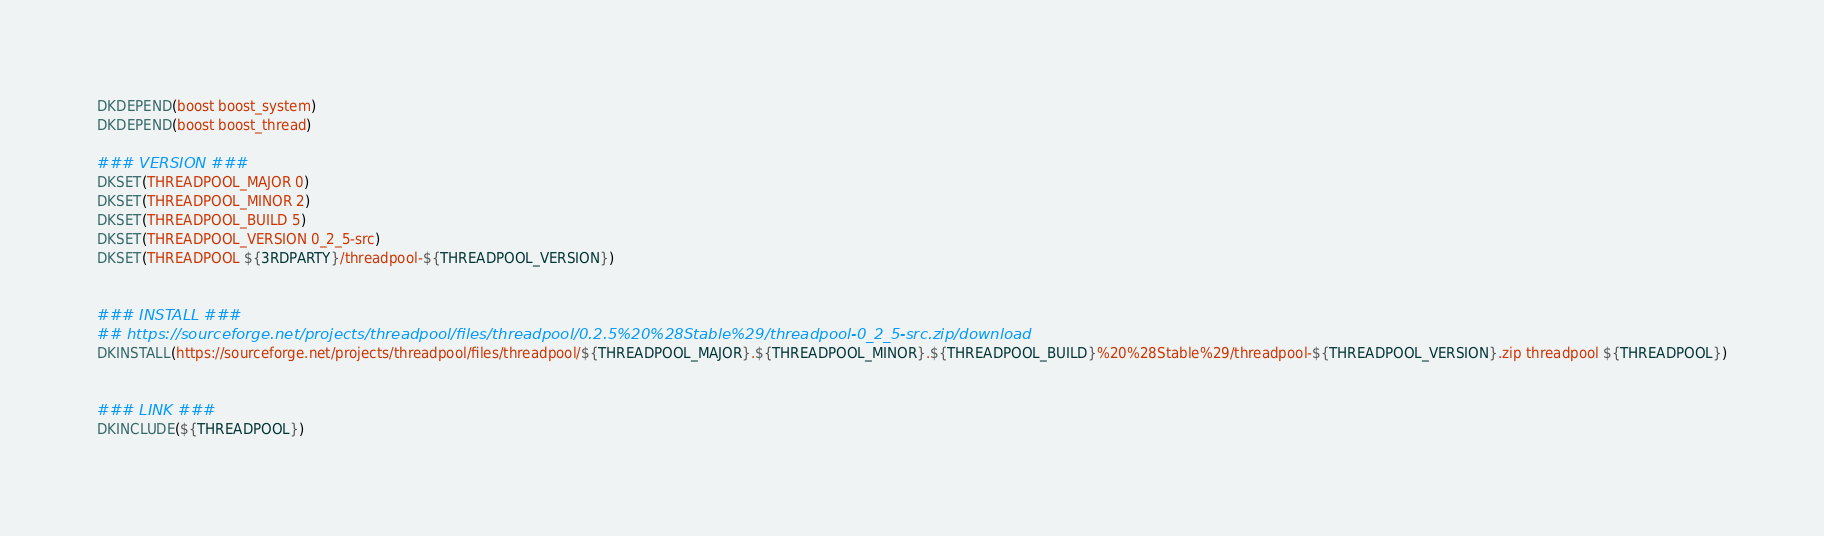<code> <loc_0><loc_0><loc_500><loc_500><_CMake_>DKDEPEND(boost boost_system)
DKDEPEND(boost boost_thread)

### VERSION ###
DKSET(THREADPOOL_MAJOR 0)
DKSET(THREADPOOL_MINOR 2)
DKSET(THREADPOOL_BUILD 5)
DKSET(THREADPOOL_VERSION 0_2_5-src)
DKSET(THREADPOOL ${3RDPARTY}/threadpool-${THREADPOOL_VERSION})


### INSTALL ###
## https://sourceforge.net/projects/threadpool/files/threadpool/0.2.5%20%28Stable%29/threadpool-0_2_5-src.zip/download
DKINSTALL(https://sourceforge.net/projects/threadpool/files/threadpool/${THREADPOOL_MAJOR}.${THREADPOOL_MINOR}.${THREADPOOL_BUILD}%20%28Stable%29/threadpool-${THREADPOOL_VERSION}.zip threadpool ${THREADPOOL})


### LINK ###
DKINCLUDE(${THREADPOOL})
</code> 